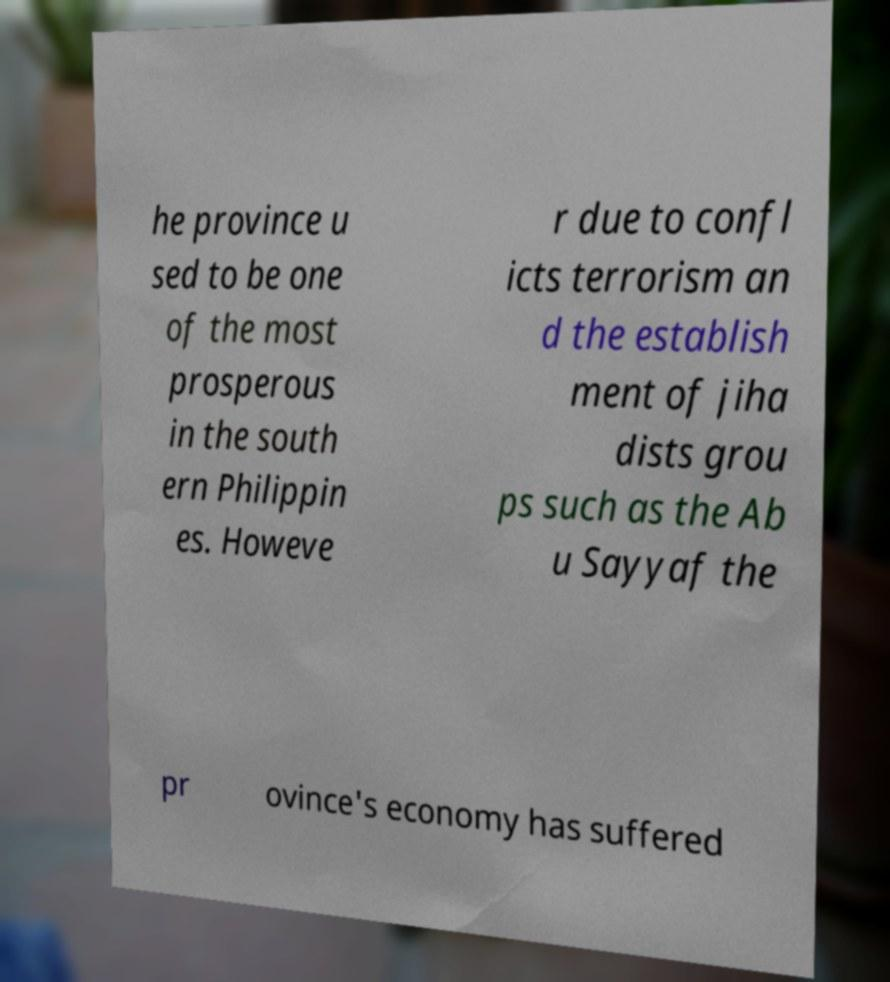Please read and relay the text visible in this image. What does it say? he province u sed to be one of the most prosperous in the south ern Philippin es. Howeve r due to confl icts terrorism an d the establish ment of jiha dists grou ps such as the Ab u Sayyaf the pr ovince's economy has suffered 